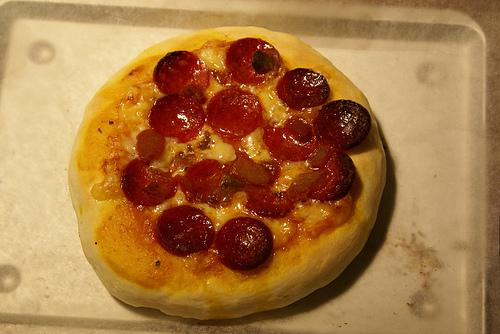Question: how did the cheese melt?
Choices:
A. It was cooked.
B. It was microwaved.
C. It was placed on a stovetop.
D. It was placed in an oven.
Answer with the letter. Answer: A Question: what shape is the pastry?
Choices:
A. Round.
B. Flat.
C. Circle.
D. Square.
Answer with the letter. Answer: C Question: what color is the cheese?
Choices:
A. Orange.
B. White.
C. Yellow.
D. Brown.
Answer with the letter. Answer: C 